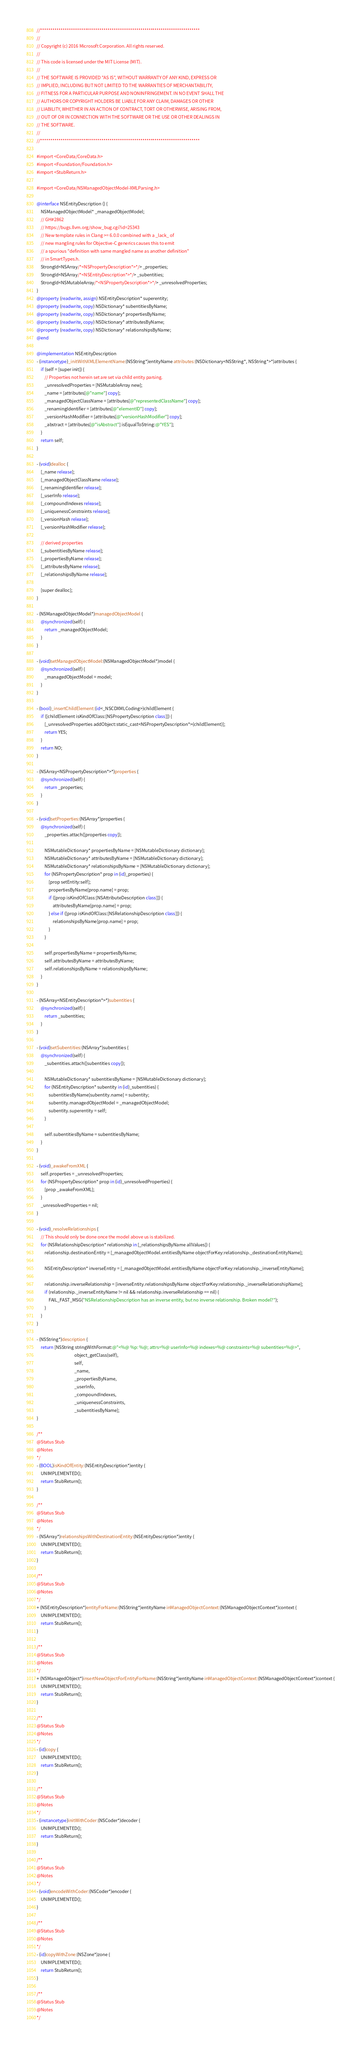Convert code to text. <code><loc_0><loc_0><loc_500><loc_500><_ObjectiveC_>//******************************************************************************
//
// Copyright (c) 2016 Microsoft Corporation. All rights reserved.
//
// This code is licensed under the MIT License (MIT).
//
// THE SOFTWARE IS PROVIDED "AS IS", WITHOUT WARRANTY OF ANY KIND, EXPRESS OR
// IMPLIED, INCLUDING BUT NOT LIMITED TO THE WARRANTIES OF MERCHANTABILITY,
// FITNESS FOR A PARTICULAR PURPOSE AND NONINFRINGEMENT. IN NO EVENT SHALL THE
// AUTHORS OR COPYRIGHT HOLDERS BE LIABLE FOR ANY CLAIM, DAMAGES OR OTHER
// LIABILITY, WHETHER IN AN ACTION OF CONTRACT, TORT OR OTHERWISE, ARISING FROM,
// OUT OF OR IN CONNECTION WITH THE SOFTWARE OR THE USE OR OTHER DEALINGS IN
// THE SOFTWARE.
//
//******************************************************************************

#import <CoreData/CoreData.h>
#import <Foundation/Foundation.h>
#import <StubReturn.h>

#import <CoreData/NSManagedObjectModel-XMLParsing.h>

@interface NSEntityDescription () {
    NSManagedObjectModel* _managedObjectModel;
    // GH#2862
    // https://bugs.llvm.org/show_bug.cgi?id=25343
    // New template rules in Clang >= 6.0.0 combined with a _lack_ of
    // new mangling rules for Objective-C generics causes this to emit
    // a spurious "definition with same mangled name as another definition"
    // in SmartTypes.h.
    StrongId<NSArray/*<NSPropertyDescription*>*/> _properties;
    StrongId<NSArray/*<NSEntityDescription*>*/> _subentities;
    StrongId<NSMutableArray/*<NSPropertyDescription*>*/> _unresolvedProperties;
}
@property (readwrite, assign) NSEntityDescription* superentity;
@property (readwrite, copy) NSDictionary* subentitiesByName;
@property (readwrite, copy) NSDictionary* propertiesByName;
@property (readwrite, copy) NSDictionary* attributesByName;
@property (readwrite, copy) NSDictionary* relationshipsByName;
@end

@implementation NSEntityDescription
- (instancetype)_initWithXMLElementName:(NSString*)entityName attributes:(NSDictionary<NSString*, NSString*>*)attributes {
    if (self = [super init]) {
        // Properties not herein set are set via child entity parsing.
        _unresolvedProperties = [NSMutableArray new];
        _name = [attributes[@"name"] copy];
        _managedObjectClassName = [attributes[@"representedClassName"] copy];
        _renamingIdentifier = [attributes[@"elementID"] copy];
        _versionHashModifier = [attributes[@"versionHashModifier"] copy];
        _abstract = [attributes[@"isAbstract"] isEqualToString:@"YES"];
    }
    return self;
}

- (void)dealloc {
    [_name release];
    [_managedObjectClassName release];
    [_renamingIdentifier release];
    [_userInfo release];
    [_compoundIndexes release];
    [_uniquenessConstraints release];
    [_versionHash release];
    [_versionHashModifier release];

    // derived properties
    [_subentitiesByName release];
    [_propertiesByName release];
    [_attributesByName release];
    [_relationshipsByName release];

    [super dealloc];
}

- (NSManagedObjectModel*)managedObjectModel {
    @synchronized(self) {
        return _managedObjectModel;
    }
}

- (void)setManagedObjectModel:(NSManagedObjectModel*)model {
    @synchronized(self) {
        _managedObjectModel = model;
    }
}

- (bool)_insertChildElement:(id<_NSCDXMLCoding>)childElement {
    if ([childElement isKindOfClass:[NSPropertyDescription class]]) {
        [_unresolvedProperties addObject:static_cast<NSPropertyDescription*>(childElement)];
        return YES;
    }
    return NO;
}

- (NSArray<NSPropertyDescription*>*)properties {
    @synchronized(self) {
        return _properties;
    }
}

- (void)setProperties:(NSArray*)properties {
    @synchronized(self) {
        _properties.attach([properties copy]);

        NSMutableDictionary* propertiesByName = [NSMutableDictionary dictionary];
        NSMutableDictionary* attributesByName = [NSMutableDictionary dictionary];
        NSMutableDictionary* relationshipsByName = [NSMutableDictionary dictionary];
        for (NSPropertyDescription* prop in (id)_properties) {
            [prop setEntity:self];
            propertiesByName[prop.name] = prop;
            if ([prop isKindOfClass:[NSAttributeDescription class]]) {
                attributesByName[prop.name] = prop;
            } else if ([prop isKindOfClass:[NSRelationshipDescription class]]) {
                relationshipsByName[prop.name] = prop;
            }
        }

        self.propertiesByName = propertiesByName;
        self.attributesByName = attributesByName;
        self.relationshipsByName = relationshipsByName;
    }
}

- (NSArray<NSEntityDescription*>*)subentities {
    @synchronized(self) {
        return _subentities;
    }
}

- (void)setSubentities:(NSArray*)subentities {
    @synchronized(self) {
        _subentities.attach([subentities copy]);

        NSMutableDictionary* subentitiesByName = [NSMutableDictionary dictionary];
        for (NSEntityDescription* subentity in (id)_subentities) {
            subentitiesByName[subentity.name] = subentity;
            subentity.managedObjectModel = _managedObjectModel;
            subentity.superentity = self;
        }

        self.subentitiesByName = subentitiesByName;
    }
}

- (void)_awakeFromXML {
    self.properties = _unresolvedProperties;
    for (NSPropertyDescription* prop in (id)_unresolvedProperties) {
        [prop _awakeFromXML];
    }
    _unresolvedProperties = nil;
}

- (void)_resolveRelationships {
    // This should only be done once the model above us is stabilized.
    for (NSRelationshipDescription* relationship in [_relationshipsByName allValues]) {
        relationship.destinationEntity = [_managedObjectModel.entitiesByName objectForKey:relationship._destinationEntityName];

        NSEntityDescription* inverseEntity = [_managedObjectModel.entitiesByName objectForKey:relationship._inverseEntityName];

        relationship.inverseRelationship = [inverseEntity.relationshipsByName objectForKey:relationship._inverseRelationshipName];
        if (relationship._inverseEntityName != nil && relationship.inverseRelationship == nil) {
            FAIL_FAST_MSG("NSRelationshipDescription has an inverse entity, but no inverse relationship. Broken model?");
        }
    }
}

- (NSString*)description {
    return [NSString stringWithFormat:@"<%@ %p: %@; attrs=%@ userInfo=%@ indexes=%@ constraints=%@ subentities=%@>",
                                      object_getClass(self),
                                      self,
                                      _name,
                                      _propertiesByName,
                                      _userInfo,
                                      _compoundIndexes,
                                      _uniquenessConstraints,
                                      _subentitiesByName];
}

/**
@Status Stub
@Notes
*/
- (BOOL)isKindOfEntity:(NSEntityDescription*)entity {
    UNIMPLEMENTED();
    return StubReturn();
}

/**
@Status Stub
@Notes
*/
- (NSArray*)relationshipsWithDestinationEntity:(NSEntityDescription*)entity {
    UNIMPLEMENTED();
    return StubReturn();
}

/**
@Status Stub
@Notes
*/
+ (NSEntityDescription*)entityForName:(NSString*)entityName inManagedObjectContext:(NSManagedObjectContext*)context {
    UNIMPLEMENTED();
    return StubReturn();
}

/**
@Status Stub
@Notes
*/
+ (NSManagedObject*)insertNewObjectForEntityForName:(NSString*)entityName inManagedObjectContext:(NSManagedObjectContext*)context {
    UNIMPLEMENTED();
    return StubReturn();
}

/**
@Status Stub
@Notes
*/
- (id)copy {
    UNIMPLEMENTED();
    return StubReturn();
}

/**
@Status Stub
@Notes
*/
- (instancetype)initWithCoder:(NSCoder*)decoder {
    UNIMPLEMENTED();
    return StubReturn();
}

/**
@Status Stub
@Notes
*/
- (void)encodeWithCoder:(NSCoder*)encoder {
    UNIMPLEMENTED();
}

/**
@Status Stub
@Notes
*/
- (id)copyWithZone:(NSZone*)zone {
    UNIMPLEMENTED();
    return StubReturn();
}

/**
@Status Stub
@Notes
*/</code> 